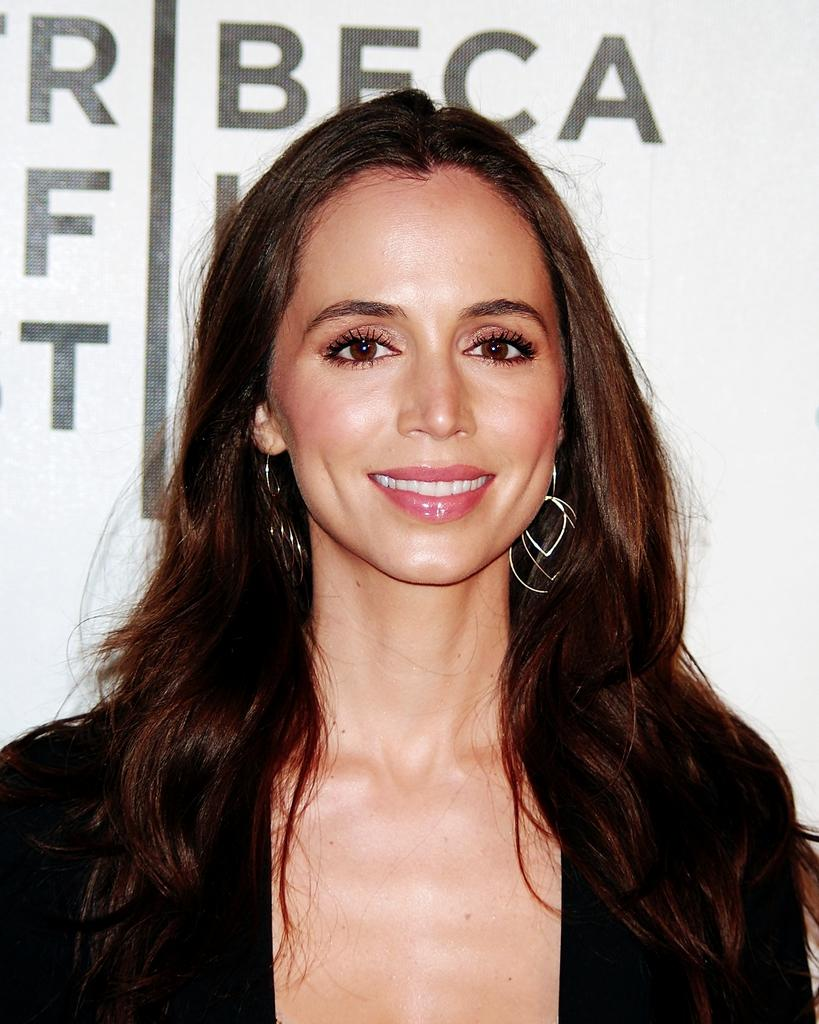What is present in the image? There is a person in the image. What can be observed about the person's attire? The person is wearing clothes. Can you describe any text visible in the image? There is text at the top of the image. What type of silk is being used in the operation depicted in the image? There is no operation or silk present in the image; it features a person wearing clothes and text at the top. 